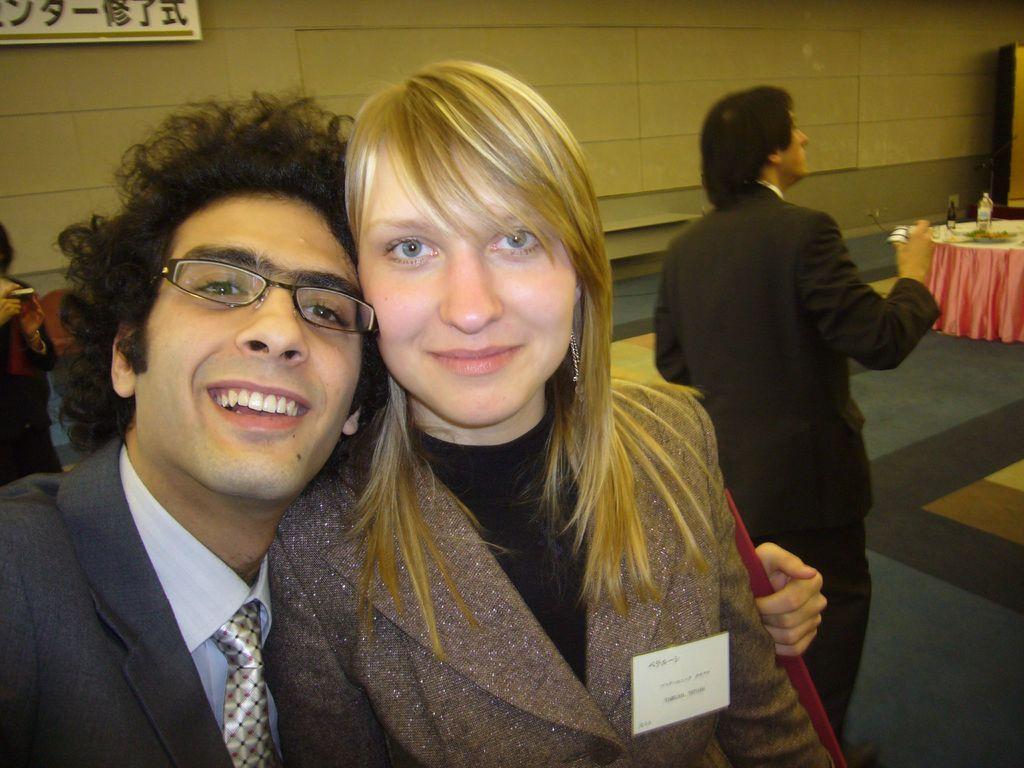Please provide a concise description of this image. In this image we can see two persons are standing, and smiling, here a man is wearing the suit, at back a person is standing, there is the table on the ground, and some objects on it, here is the wall. 